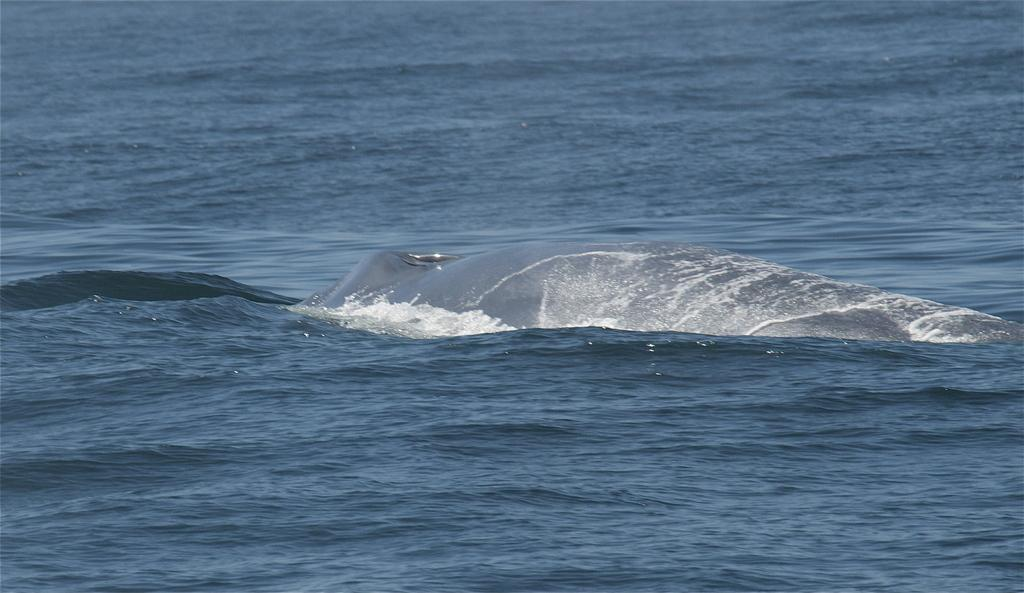What type of body of water is visible in the image? There is an ocean in the image. What animal can be seen in the ocean? There is a shark in the ocean. What type of history can be seen in the image? There is no history visible in the image; it features an ocean and a shark. What type of brass object is present in the image? There is no brass object present in the image. 